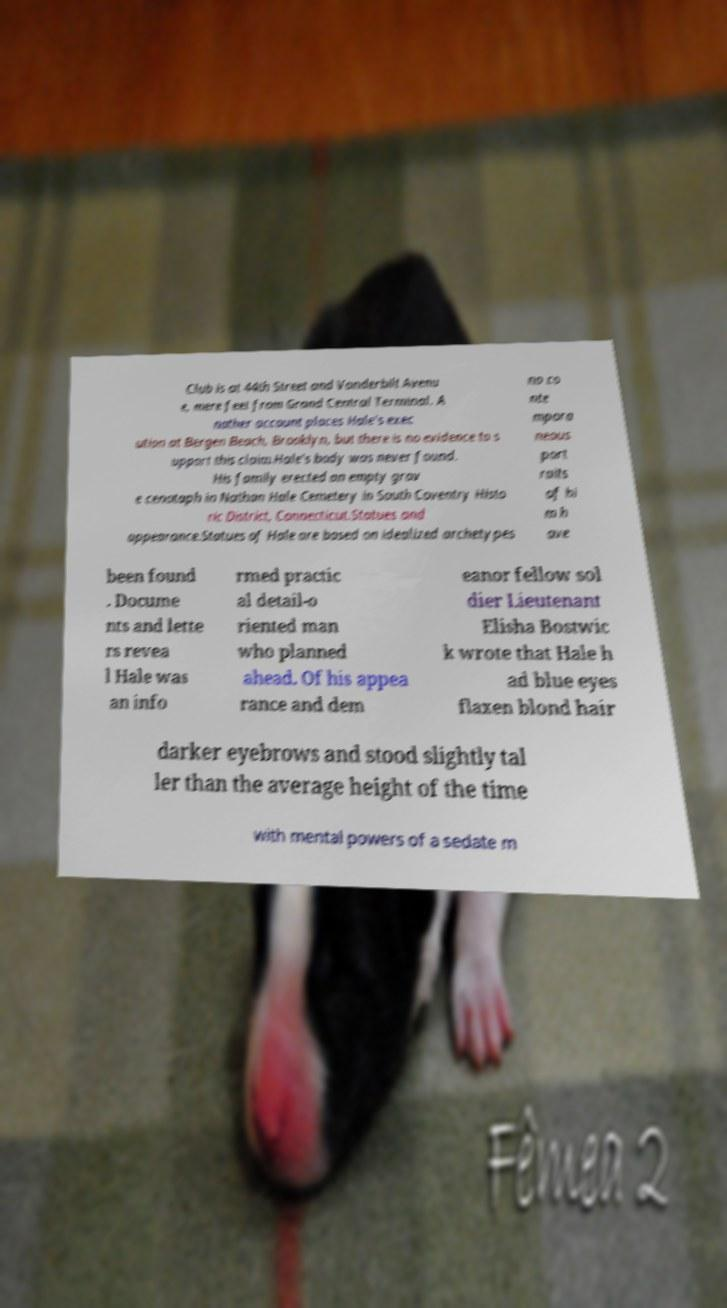Can you read and provide the text displayed in the image?This photo seems to have some interesting text. Can you extract and type it out for me? Club is at 44th Street and Vanderbilt Avenu e, mere feet from Grand Central Terminal. A nother account places Hale's exec ution at Bergen Beach, Brooklyn, but there is no evidence to s upport this claim.Hale's body was never found. His family erected an empty grav e cenotaph in Nathan Hale Cemetery in South Coventry Histo ric District, Connecticut.Statues and appearance.Statues of Hale are based on idealized archetypes no co nte mpora neous port raits of hi m h ave been found . Docume nts and lette rs revea l Hale was an info rmed practic al detail-o riented man who planned ahead. Of his appea rance and dem eanor fellow sol dier Lieutenant Elisha Bostwic k wrote that Hale h ad blue eyes flaxen blond hair darker eyebrows and stood slightly tal ler than the average height of the time with mental powers of a sedate m 